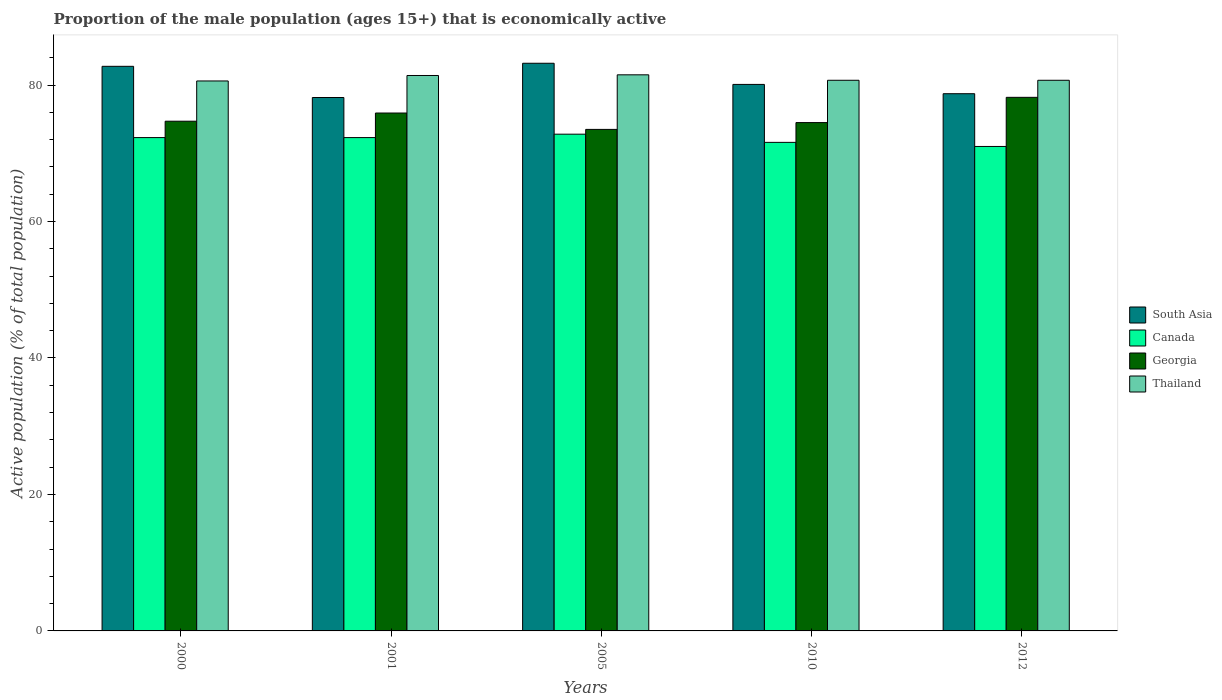How many different coloured bars are there?
Ensure brevity in your answer.  4. Are the number of bars per tick equal to the number of legend labels?
Give a very brief answer. Yes. Are the number of bars on each tick of the X-axis equal?
Keep it short and to the point. Yes. How many bars are there on the 2nd tick from the left?
Ensure brevity in your answer.  4. How many bars are there on the 3rd tick from the right?
Your answer should be very brief. 4. In how many cases, is the number of bars for a given year not equal to the number of legend labels?
Provide a succinct answer. 0. What is the proportion of the male population that is economically active in Canada in 2012?
Your response must be concise. 71. Across all years, what is the maximum proportion of the male population that is economically active in Georgia?
Ensure brevity in your answer.  78.2. Across all years, what is the minimum proportion of the male population that is economically active in Canada?
Your answer should be very brief. 71. In which year was the proportion of the male population that is economically active in Thailand minimum?
Make the answer very short. 2000. What is the total proportion of the male population that is economically active in Georgia in the graph?
Provide a succinct answer. 376.8. What is the difference between the proportion of the male population that is economically active in South Asia in 2000 and that in 2001?
Provide a succinct answer. 4.57. What is the difference between the proportion of the male population that is economically active in Georgia in 2010 and the proportion of the male population that is economically active in Thailand in 2001?
Ensure brevity in your answer.  -6.9. What is the average proportion of the male population that is economically active in South Asia per year?
Your answer should be very brief. 80.59. What is the ratio of the proportion of the male population that is economically active in Canada in 2000 to that in 2005?
Your response must be concise. 0.99. Is the difference between the proportion of the male population that is economically active in Thailand in 2010 and 2012 greater than the difference between the proportion of the male population that is economically active in Georgia in 2010 and 2012?
Give a very brief answer. Yes. What is the difference between the highest and the second highest proportion of the male population that is economically active in Thailand?
Provide a succinct answer. 0.1. What is the difference between the highest and the lowest proportion of the male population that is economically active in Thailand?
Offer a terse response. 0.9. Is the sum of the proportion of the male population that is economically active in Georgia in 2001 and 2012 greater than the maximum proportion of the male population that is economically active in Thailand across all years?
Your answer should be compact. Yes. What does the 3rd bar from the left in 2005 represents?
Your response must be concise. Georgia. What does the 1st bar from the right in 2001 represents?
Give a very brief answer. Thailand. Is it the case that in every year, the sum of the proportion of the male population that is economically active in Canada and proportion of the male population that is economically active in South Asia is greater than the proportion of the male population that is economically active in Georgia?
Give a very brief answer. Yes. How many bars are there?
Provide a succinct answer. 20. How many years are there in the graph?
Provide a short and direct response. 5. Does the graph contain any zero values?
Keep it short and to the point. No. Does the graph contain grids?
Ensure brevity in your answer.  No. What is the title of the graph?
Your response must be concise. Proportion of the male population (ages 15+) that is economically active. Does "Timor-Leste" appear as one of the legend labels in the graph?
Provide a succinct answer. No. What is the label or title of the X-axis?
Your answer should be very brief. Years. What is the label or title of the Y-axis?
Your answer should be very brief. Active population (% of total population). What is the Active population (% of total population) in South Asia in 2000?
Provide a short and direct response. 82.74. What is the Active population (% of total population) of Canada in 2000?
Offer a terse response. 72.3. What is the Active population (% of total population) of Georgia in 2000?
Offer a very short reply. 74.7. What is the Active population (% of total population) in Thailand in 2000?
Offer a very short reply. 80.6. What is the Active population (% of total population) in South Asia in 2001?
Give a very brief answer. 78.17. What is the Active population (% of total population) of Canada in 2001?
Your answer should be very brief. 72.3. What is the Active population (% of total population) of Georgia in 2001?
Your answer should be compact. 75.9. What is the Active population (% of total population) of Thailand in 2001?
Keep it short and to the point. 81.4. What is the Active population (% of total population) of South Asia in 2005?
Give a very brief answer. 83.19. What is the Active population (% of total population) of Canada in 2005?
Your response must be concise. 72.8. What is the Active population (% of total population) in Georgia in 2005?
Your answer should be very brief. 73.5. What is the Active population (% of total population) in Thailand in 2005?
Your response must be concise. 81.5. What is the Active population (% of total population) of South Asia in 2010?
Your answer should be compact. 80.09. What is the Active population (% of total population) in Canada in 2010?
Provide a succinct answer. 71.6. What is the Active population (% of total population) in Georgia in 2010?
Offer a very short reply. 74.5. What is the Active population (% of total population) of Thailand in 2010?
Your response must be concise. 80.7. What is the Active population (% of total population) of South Asia in 2012?
Your answer should be very brief. 78.73. What is the Active population (% of total population) in Canada in 2012?
Ensure brevity in your answer.  71. What is the Active population (% of total population) in Georgia in 2012?
Ensure brevity in your answer.  78.2. What is the Active population (% of total population) of Thailand in 2012?
Your response must be concise. 80.7. Across all years, what is the maximum Active population (% of total population) in South Asia?
Keep it short and to the point. 83.19. Across all years, what is the maximum Active population (% of total population) in Canada?
Provide a short and direct response. 72.8. Across all years, what is the maximum Active population (% of total population) in Georgia?
Your answer should be very brief. 78.2. Across all years, what is the maximum Active population (% of total population) in Thailand?
Offer a very short reply. 81.5. Across all years, what is the minimum Active population (% of total population) of South Asia?
Your answer should be compact. 78.17. Across all years, what is the minimum Active population (% of total population) of Canada?
Keep it short and to the point. 71. Across all years, what is the minimum Active population (% of total population) in Georgia?
Your answer should be compact. 73.5. Across all years, what is the minimum Active population (% of total population) in Thailand?
Your answer should be very brief. 80.6. What is the total Active population (% of total population) in South Asia in the graph?
Keep it short and to the point. 402.94. What is the total Active population (% of total population) in Canada in the graph?
Your answer should be very brief. 360. What is the total Active population (% of total population) of Georgia in the graph?
Your answer should be very brief. 376.8. What is the total Active population (% of total population) of Thailand in the graph?
Give a very brief answer. 404.9. What is the difference between the Active population (% of total population) of South Asia in 2000 and that in 2001?
Your answer should be very brief. 4.57. What is the difference between the Active population (% of total population) in Georgia in 2000 and that in 2001?
Provide a succinct answer. -1.2. What is the difference between the Active population (% of total population) in South Asia in 2000 and that in 2005?
Your answer should be very brief. -0.45. What is the difference between the Active population (% of total population) in Georgia in 2000 and that in 2005?
Your response must be concise. 1.2. What is the difference between the Active population (% of total population) in South Asia in 2000 and that in 2010?
Make the answer very short. 2.65. What is the difference between the Active population (% of total population) of Canada in 2000 and that in 2010?
Your answer should be very brief. 0.7. What is the difference between the Active population (% of total population) in Georgia in 2000 and that in 2010?
Your response must be concise. 0.2. What is the difference between the Active population (% of total population) in Thailand in 2000 and that in 2010?
Make the answer very short. -0.1. What is the difference between the Active population (% of total population) of South Asia in 2000 and that in 2012?
Offer a terse response. 4.01. What is the difference between the Active population (% of total population) of Canada in 2000 and that in 2012?
Offer a terse response. 1.3. What is the difference between the Active population (% of total population) in Georgia in 2000 and that in 2012?
Your response must be concise. -3.5. What is the difference between the Active population (% of total population) of Thailand in 2000 and that in 2012?
Offer a very short reply. -0.1. What is the difference between the Active population (% of total population) of South Asia in 2001 and that in 2005?
Make the answer very short. -5.02. What is the difference between the Active population (% of total population) in Canada in 2001 and that in 2005?
Provide a succinct answer. -0.5. What is the difference between the Active population (% of total population) of Georgia in 2001 and that in 2005?
Your response must be concise. 2.4. What is the difference between the Active population (% of total population) of South Asia in 2001 and that in 2010?
Your answer should be very brief. -1.92. What is the difference between the Active population (% of total population) in Georgia in 2001 and that in 2010?
Provide a succinct answer. 1.4. What is the difference between the Active population (% of total population) in Thailand in 2001 and that in 2010?
Your response must be concise. 0.7. What is the difference between the Active population (% of total population) in South Asia in 2001 and that in 2012?
Your answer should be compact. -0.56. What is the difference between the Active population (% of total population) of Canada in 2001 and that in 2012?
Ensure brevity in your answer.  1.3. What is the difference between the Active population (% of total population) of Georgia in 2001 and that in 2012?
Provide a succinct answer. -2.3. What is the difference between the Active population (% of total population) of South Asia in 2005 and that in 2010?
Give a very brief answer. 3.1. What is the difference between the Active population (% of total population) of Georgia in 2005 and that in 2010?
Keep it short and to the point. -1. What is the difference between the Active population (% of total population) of Thailand in 2005 and that in 2010?
Make the answer very short. 0.8. What is the difference between the Active population (% of total population) of South Asia in 2005 and that in 2012?
Offer a very short reply. 4.46. What is the difference between the Active population (% of total population) of Georgia in 2005 and that in 2012?
Make the answer very short. -4.7. What is the difference between the Active population (% of total population) in Thailand in 2005 and that in 2012?
Provide a succinct answer. 0.8. What is the difference between the Active population (% of total population) of South Asia in 2010 and that in 2012?
Provide a succinct answer. 1.36. What is the difference between the Active population (% of total population) of Canada in 2010 and that in 2012?
Provide a succinct answer. 0.6. What is the difference between the Active population (% of total population) of South Asia in 2000 and the Active population (% of total population) of Canada in 2001?
Keep it short and to the point. 10.44. What is the difference between the Active population (% of total population) in South Asia in 2000 and the Active population (% of total population) in Georgia in 2001?
Your answer should be compact. 6.84. What is the difference between the Active population (% of total population) in South Asia in 2000 and the Active population (% of total population) in Thailand in 2001?
Provide a succinct answer. 1.34. What is the difference between the Active population (% of total population) of Canada in 2000 and the Active population (% of total population) of Georgia in 2001?
Give a very brief answer. -3.6. What is the difference between the Active population (% of total population) of Canada in 2000 and the Active population (% of total population) of Thailand in 2001?
Your answer should be very brief. -9.1. What is the difference between the Active population (% of total population) of South Asia in 2000 and the Active population (% of total population) of Canada in 2005?
Offer a very short reply. 9.94. What is the difference between the Active population (% of total population) in South Asia in 2000 and the Active population (% of total population) in Georgia in 2005?
Offer a terse response. 9.24. What is the difference between the Active population (% of total population) in South Asia in 2000 and the Active population (% of total population) in Thailand in 2005?
Make the answer very short. 1.24. What is the difference between the Active population (% of total population) of Canada in 2000 and the Active population (% of total population) of Thailand in 2005?
Your answer should be very brief. -9.2. What is the difference between the Active population (% of total population) in South Asia in 2000 and the Active population (% of total population) in Canada in 2010?
Keep it short and to the point. 11.14. What is the difference between the Active population (% of total population) in South Asia in 2000 and the Active population (% of total population) in Georgia in 2010?
Your answer should be compact. 8.24. What is the difference between the Active population (% of total population) of South Asia in 2000 and the Active population (% of total population) of Thailand in 2010?
Offer a terse response. 2.04. What is the difference between the Active population (% of total population) in Canada in 2000 and the Active population (% of total population) in Thailand in 2010?
Your response must be concise. -8.4. What is the difference between the Active population (% of total population) of South Asia in 2000 and the Active population (% of total population) of Canada in 2012?
Your answer should be very brief. 11.74. What is the difference between the Active population (% of total population) in South Asia in 2000 and the Active population (% of total population) in Georgia in 2012?
Make the answer very short. 4.54. What is the difference between the Active population (% of total population) in South Asia in 2000 and the Active population (% of total population) in Thailand in 2012?
Provide a succinct answer. 2.04. What is the difference between the Active population (% of total population) in Canada in 2000 and the Active population (% of total population) in Thailand in 2012?
Your response must be concise. -8.4. What is the difference between the Active population (% of total population) in South Asia in 2001 and the Active population (% of total population) in Canada in 2005?
Give a very brief answer. 5.37. What is the difference between the Active population (% of total population) in South Asia in 2001 and the Active population (% of total population) in Georgia in 2005?
Keep it short and to the point. 4.67. What is the difference between the Active population (% of total population) in South Asia in 2001 and the Active population (% of total population) in Thailand in 2005?
Provide a succinct answer. -3.33. What is the difference between the Active population (% of total population) in Canada in 2001 and the Active population (% of total population) in Georgia in 2005?
Offer a very short reply. -1.2. What is the difference between the Active population (% of total population) in South Asia in 2001 and the Active population (% of total population) in Canada in 2010?
Offer a very short reply. 6.57. What is the difference between the Active population (% of total population) of South Asia in 2001 and the Active population (% of total population) of Georgia in 2010?
Your answer should be very brief. 3.67. What is the difference between the Active population (% of total population) in South Asia in 2001 and the Active population (% of total population) in Thailand in 2010?
Provide a short and direct response. -2.53. What is the difference between the Active population (% of total population) of Canada in 2001 and the Active population (% of total population) of Georgia in 2010?
Ensure brevity in your answer.  -2.2. What is the difference between the Active population (% of total population) in South Asia in 2001 and the Active population (% of total population) in Canada in 2012?
Ensure brevity in your answer.  7.17. What is the difference between the Active population (% of total population) of South Asia in 2001 and the Active population (% of total population) of Georgia in 2012?
Provide a short and direct response. -0.03. What is the difference between the Active population (% of total population) in South Asia in 2001 and the Active population (% of total population) in Thailand in 2012?
Keep it short and to the point. -2.53. What is the difference between the Active population (% of total population) in Canada in 2001 and the Active population (% of total population) in Georgia in 2012?
Make the answer very short. -5.9. What is the difference between the Active population (% of total population) in Canada in 2001 and the Active population (% of total population) in Thailand in 2012?
Ensure brevity in your answer.  -8.4. What is the difference between the Active population (% of total population) of Georgia in 2001 and the Active population (% of total population) of Thailand in 2012?
Your answer should be compact. -4.8. What is the difference between the Active population (% of total population) of South Asia in 2005 and the Active population (% of total population) of Canada in 2010?
Your answer should be compact. 11.59. What is the difference between the Active population (% of total population) of South Asia in 2005 and the Active population (% of total population) of Georgia in 2010?
Make the answer very short. 8.69. What is the difference between the Active population (% of total population) of South Asia in 2005 and the Active population (% of total population) of Thailand in 2010?
Ensure brevity in your answer.  2.49. What is the difference between the Active population (% of total population) in Georgia in 2005 and the Active population (% of total population) in Thailand in 2010?
Give a very brief answer. -7.2. What is the difference between the Active population (% of total population) of South Asia in 2005 and the Active population (% of total population) of Canada in 2012?
Your answer should be very brief. 12.19. What is the difference between the Active population (% of total population) of South Asia in 2005 and the Active population (% of total population) of Georgia in 2012?
Keep it short and to the point. 4.99. What is the difference between the Active population (% of total population) of South Asia in 2005 and the Active population (% of total population) of Thailand in 2012?
Your answer should be very brief. 2.49. What is the difference between the Active population (% of total population) in Canada in 2005 and the Active population (% of total population) in Thailand in 2012?
Make the answer very short. -7.9. What is the difference between the Active population (% of total population) of South Asia in 2010 and the Active population (% of total population) of Canada in 2012?
Ensure brevity in your answer.  9.09. What is the difference between the Active population (% of total population) in South Asia in 2010 and the Active population (% of total population) in Georgia in 2012?
Your response must be concise. 1.89. What is the difference between the Active population (% of total population) in South Asia in 2010 and the Active population (% of total population) in Thailand in 2012?
Provide a short and direct response. -0.61. What is the average Active population (% of total population) in South Asia per year?
Provide a succinct answer. 80.59. What is the average Active population (% of total population) in Georgia per year?
Ensure brevity in your answer.  75.36. What is the average Active population (% of total population) in Thailand per year?
Ensure brevity in your answer.  80.98. In the year 2000, what is the difference between the Active population (% of total population) in South Asia and Active population (% of total population) in Canada?
Keep it short and to the point. 10.44. In the year 2000, what is the difference between the Active population (% of total population) in South Asia and Active population (% of total population) in Georgia?
Provide a short and direct response. 8.04. In the year 2000, what is the difference between the Active population (% of total population) of South Asia and Active population (% of total population) of Thailand?
Provide a short and direct response. 2.14. In the year 2000, what is the difference between the Active population (% of total population) of Canada and Active population (% of total population) of Georgia?
Provide a short and direct response. -2.4. In the year 2001, what is the difference between the Active population (% of total population) in South Asia and Active population (% of total population) in Canada?
Provide a short and direct response. 5.87. In the year 2001, what is the difference between the Active population (% of total population) in South Asia and Active population (% of total population) in Georgia?
Offer a very short reply. 2.27. In the year 2001, what is the difference between the Active population (% of total population) in South Asia and Active population (% of total population) in Thailand?
Keep it short and to the point. -3.23. In the year 2001, what is the difference between the Active population (% of total population) of Canada and Active population (% of total population) of Thailand?
Make the answer very short. -9.1. In the year 2005, what is the difference between the Active population (% of total population) of South Asia and Active population (% of total population) of Canada?
Give a very brief answer. 10.39. In the year 2005, what is the difference between the Active population (% of total population) of South Asia and Active population (% of total population) of Georgia?
Ensure brevity in your answer.  9.69. In the year 2005, what is the difference between the Active population (% of total population) of South Asia and Active population (% of total population) of Thailand?
Your answer should be very brief. 1.69. In the year 2005, what is the difference between the Active population (% of total population) of Georgia and Active population (% of total population) of Thailand?
Make the answer very short. -8. In the year 2010, what is the difference between the Active population (% of total population) in South Asia and Active population (% of total population) in Canada?
Give a very brief answer. 8.49. In the year 2010, what is the difference between the Active population (% of total population) of South Asia and Active population (% of total population) of Georgia?
Keep it short and to the point. 5.59. In the year 2010, what is the difference between the Active population (% of total population) in South Asia and Active population (% of total population) in Thailand?
Provide a short and direct response. -0.61. In the year 2010, what is the difference between the Active population (% of total population) of Canada and Active population (% of total population) of Georgia?
Keep it short and to the point. -2.9. In the year 2010, what is the difference between the Active population (% of total population) in Georgia and Active population (% of total population) in Thailand?
Keep it short and to the point. -6.2. In the year 2012, what is the difference between the Active population (% of total population) in South Asia and Active population (% of total population) in Canada?
Ensure brevity in your answer.  7.73. In the year 2012, what is the difference between the Active population (% of total population) in South Asia and Active population (% of total population) in Georgia?
Keep it short and to the point. 0.53. In the year 2012, what is the difference between the Active population (% of total population) of South Asia and Active population (% of total population) of Thailand?
Provide a succinct answer. -1.97. In the year 2012, what is the difference between the Active population (% of total population) in Canada and Active population (% of total population) in Thailand?
Ensure brevity in your answer.  -9.7. What is the ratio of the Active population (% of total population) in South Asia in 2000 to that in 2001?
Your answer should be compact. 1.06. What is the ratio of the Active population (% of total population) in Canada in 2000 to that in 2001?
Offer a terse response. 1. What is the ratio of the Active population (% of total population) of Georgia in 2000 to that in 2001?
Your response must be concise. 0.98. What is the ratio of the Active population (% of total population) of Thailand in 2000 to that in 2001?
Offer a very short reply. 0.99. What is the ratio of the Active population (% of total population) of Georgia in 2000 to that in 2005?
Your answer should be compact. 1.02. What is the ratio of the Active population (% of total population) of Thailand in 2000 to that in 2005?
Your answer should be very brief. 0.99. What is the ratio of the Active population (% of total population) of South Asia in 2000 to that in 2010?
Provide a short and direct response. 1.03. What is the ratio of the Active population (% of total population) in Canada in 2000 to that in 2010?
Offer a terse response. 1.01. What is the ratio of the Active population (% of total population) in South Asia in 2000 to that in 2012?
Your answer should be compact. 1.05. What is the ratio of the Active population (% of total population) of Canada in 2000 to that in 2012?
Make the answer very short. 1.02. What is the ratio of the Active population (% of total population) of Georgia in 2000 to that in 2012?
Your answer should be very brief. 0.96. What is the ratio of the Active population (% of total population) of Thailand in 2000 to that in 2012?
Offer a terse response. 1. What is the ratio of the Active population (% of total population) of South Asia in 2001 to that in 2005?
Give a very brief answer. 0.94. What is the ratio of the Active population (% of total population) in Canada in 2001 to that in 2005?
Offer a very short reply. 0.99. What is the ratio of the Active population (% of total population) of Georgia in 2001 to that in 2005?
Give a very brief answer. 1.03. What is the ratio of the Active population (% of total population) of South Asia in 2001 to that in 2010?
Your answer should be very brief. 0.98. What is the ratio of the Active population (% of total population) of Canada in 2001 to that in 2010?
Ensure brevity in your answer.  1.01. What is the ratio of the Active population (% of total population) in Georgia in 2001 to that in 2010?
Provide a short and direct response. 1.02. What is the ratio of the Active population (% of total population) of Thailand in 2001 to that in 2010?
Your answer should be compact. 1.01. What is the ratio of the Active population (% of total population) in South Asia in 2001 to that in 2012?
Offer a terse response. 0.99. What is the ratio of the Active population (% of total population) in Canada in 2001 to that in 2012?
Your response must be concise. 1.02. What is the ratio of the Active population (% of total population) in Georgia in 2001 to that in 2012?
Ensure brevity in your answer.  0.97. What is the ratio of the Active population (% of total population) in Thailand in 2001 to that in 2012?
Make the answer very short. 1.01. What is the ratio of the Active population (% of total population) in South Asia in 2005 to that in 2010?
Provide a succinct answer. 1.04. What is the ratio of the Active population (% of total population) of Canada in 2005 to that in 2010?
Your response must be concise. 1.02. What is the ratio of the Active population (% of total population) of Georgia in 2005 to that in 2010?
Offer a terse response. 0.99. What is the ratio of the Active population (% of total population) of Thailand in 2005 to that in 2010?
Make the answer very short. 1.01. What is the ratio of the Active population (% of total population) in South Asia in 2005 to that in 2012?
Provide a succinct answer. 1.06. What is the ratio of the Active population (% of total population) of Canada in 2005 to that in 2012?
Make the answer very short. 1.03. What is the ratio of the Active population (% of total population) in Georgia in 2005 to that in 2012?
Make the answer very short. 0.94. What is the ratio of the Active population (% of total population) in Thailand in 2005 to that in 2012?
Make the answer very short. 1.01. What is the ratio of the Active population (% of total population) of South Asia in 2010 to that in 2012?
Offer a very short reply. 1.02. What is the ratio of the Active population (% of total population) in Canada in 2010 to that in 2012?
Offer a very short reply. 1.01. What is the ratio of the Active population (% of total population) in Georgia in 2010 to that in 2012?
Your answer should be very brief. 0.95. What is the ratio of the Active population (% of total population) of Thailand in 2010 to that in 2012?
Offer a terse response. 1. What is the difference between the highest and the second highest Active population (% of total population) in South Asia?
Provide a short and direct response. 0.45. What is the difference between the highest and the second highest Active population (% of total population) of Canada?
Make the answer very short. 0.5. What is the difference between the highest and the second highest Active population (% of total population) in Georgia?
Give a very brief answer. 2.3. What is the difference between the highest and the lowest Active population (% of total population) of South Asia?
Your answer should be compact. 5.02. What is the difference between the highest and the lowest Active population (% of total population) of Canada?
Offer a terse response. 1.8. What is the difference between the highest and the lowest Active population (% of total population) in Georgia?
Your answer should be compact. 4.7. What is the difference between the highest and the lowest Active population (% of total population) of Thailand?
Provide a short and direct response. 0.9. 